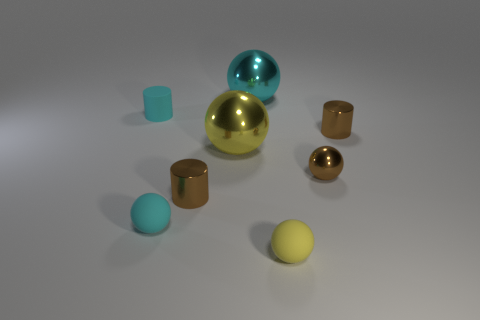There is a big object that is the same material as the big cyan sphere; what is its color?
Your answer should be compact. Yellow. Is there anything else that has the same size as the yellow shiny thing?
Ensure brevity in your answer.  Yes. There is a big shiny object to the left of the big cyan object; is it the same color as the small shiny cylinder right of the yellow rubber sphere?
Offer a very short reply. No. Is the number of cyan matte cylinders in front of the yellow metal ball greater than the number of cylinders on the right side of the cyan shiny ball?
Ensure brevity in your answer.  No. What color is the other small shiny object that is the same shape as the yellow metallic thing?
Ensure brevity in your answer.  Brown. Are there any other things that are the same shape as the large cyan object?
Ensure brevity in your answer.  Yes. There is a large cyan thing; does it have the same shape as the matte thing that is on the right side of the cyan metal ball?
Your answer should be compact. Yes. What number of other things are there of the same material as the tiny brown sphere
Give a very brief answer. 4. There is a rubber cylinder; is its color the same as the small ball that is to the left of the cyan metal sphere?
Offer a terse response. Yes. There is a tiny ball that is left of the small yellow ball; what is it made of?
Provide a short and direct response. Rubber. 